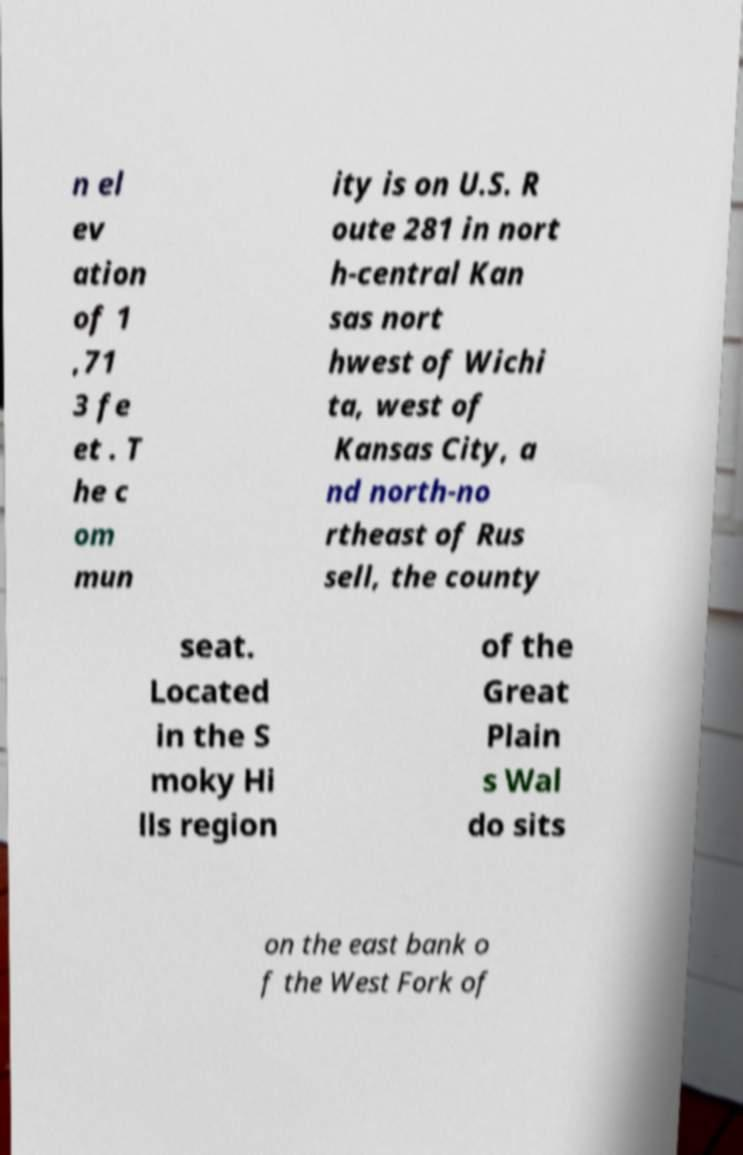Please read and relay the text visible in this image. What does it say? n el ev ation of 1 ,71 3 fe et . T he c om mun ity is on U.S. R oute 281 in nort h-central Kan sas nort hwest of Wichi ta, west of Kansas City, a nd north-no rtheast of Rus sell, the county seat. Located in the S moky Hi lls region of the Great Plain s Wal do sits on the east bank o f the West Fork of 